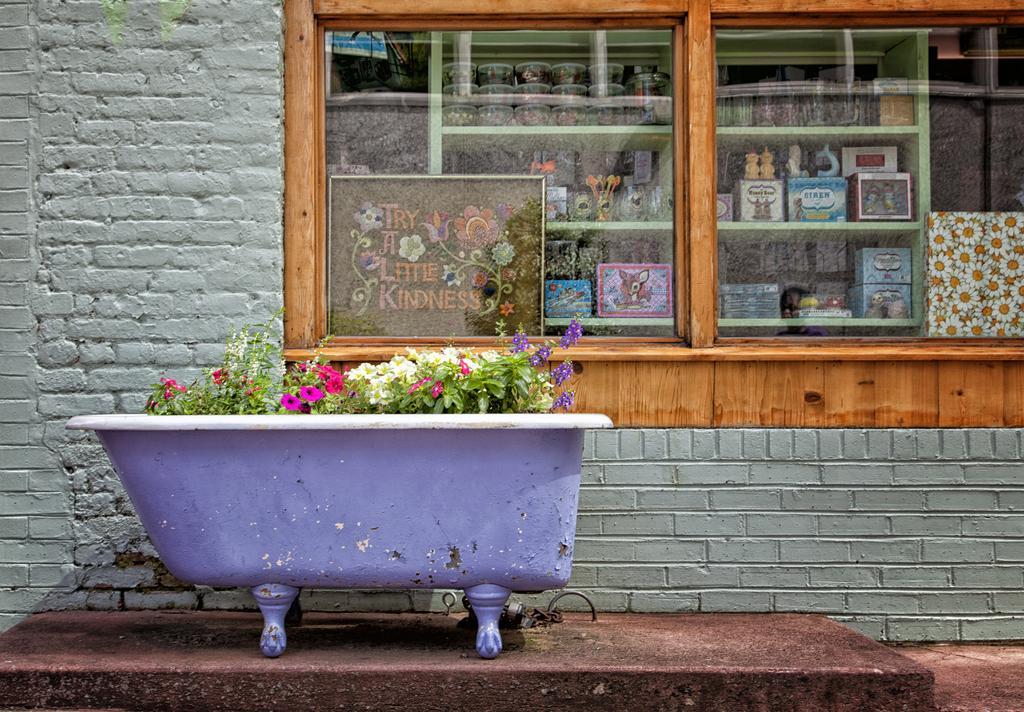Can you describe this image briefly? In this picture I can see there is a flower pot here and it has few flowers in it and there is a wall and there is a window here and there are few objects placed here in the shelf. 